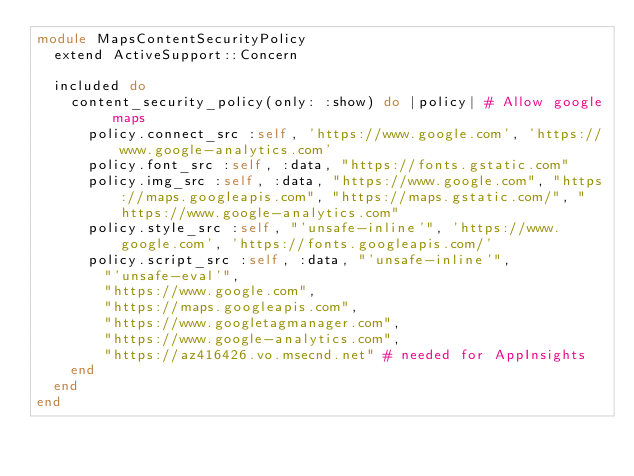<code> <loc_0><loc_0><loc_500><loc_500><_Ruby_>module MapsContentSecurityPolicy
  extend ActiveSupport::Concern

  included do
    content_security_policy(only: :show) do |policy| # Allow google maps
      policy.connect_src :self, 'https://www.google.com', 'https://www.google-analytics.com'
      policy.font_src :self, :data, "https://fonts.gstatic.com"
      policy.img_src :self, :data, "https://www.google.com", "https://maps.googleapis.com", "https://maps.gstatic.com/", "https://www.google-analytics.com"
      policy.style_src :self, "'unsafe-inline'", 'https://www.google.com', 'https://fonts.googleapis.com/'
      policy.script_src :self, :data, "'unsafe-inline'",
        "'unsafe-eval'",
        "https://www.google.com",
        "https://maps.googleapis.com",
        "https://www.googletagmanager.com",
        "https://www.google-analytics.com",
        "https://az416426.vo.msecnd.net" # needed for AppInsights
    end
  end
end
</code> 